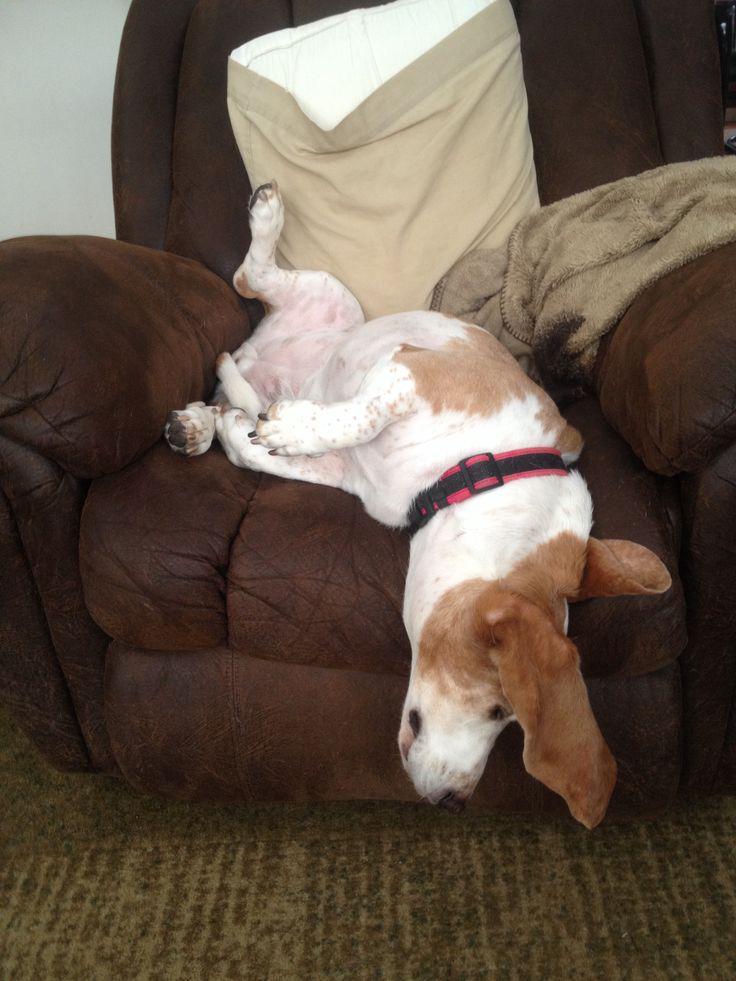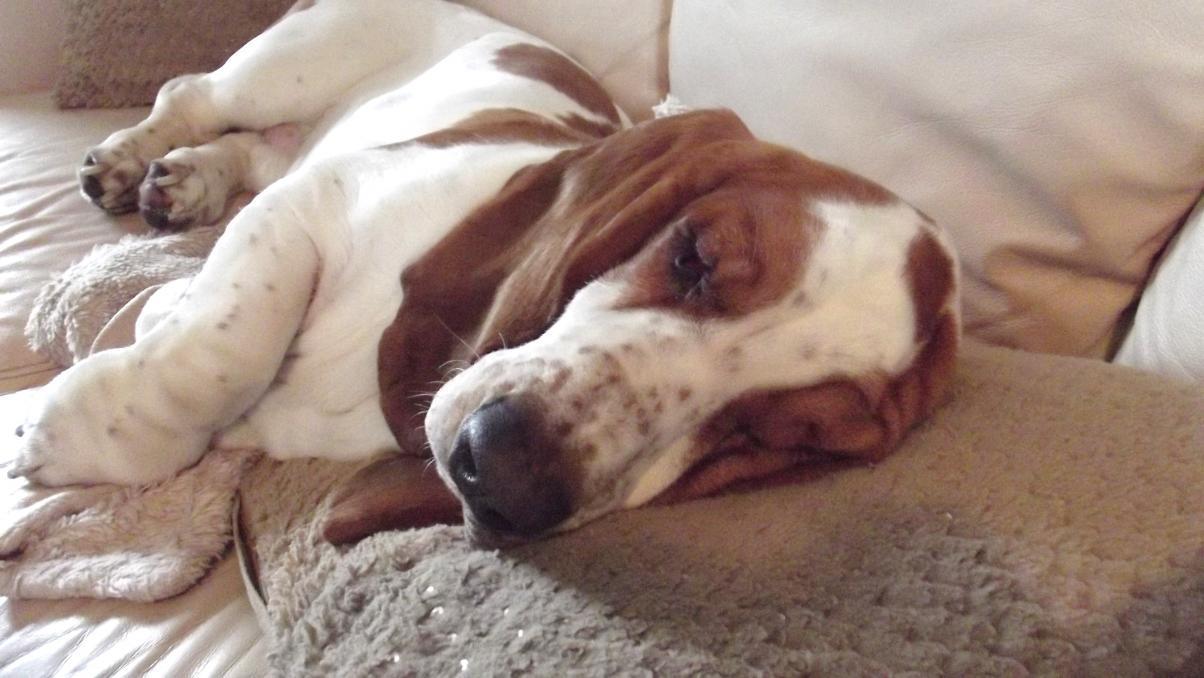The first image is the image on the left, the second image is the image on the right. For the images shown, is this caption "There is a single dog sleeping in the image on the left." true? Answer yes or no. Yes. The first image is the image on the left, the second image is the image on the right. Considering the images on both sides, is "There is no more than one sleeping dog in the right image." valid? Answer yes or no. Yes. 